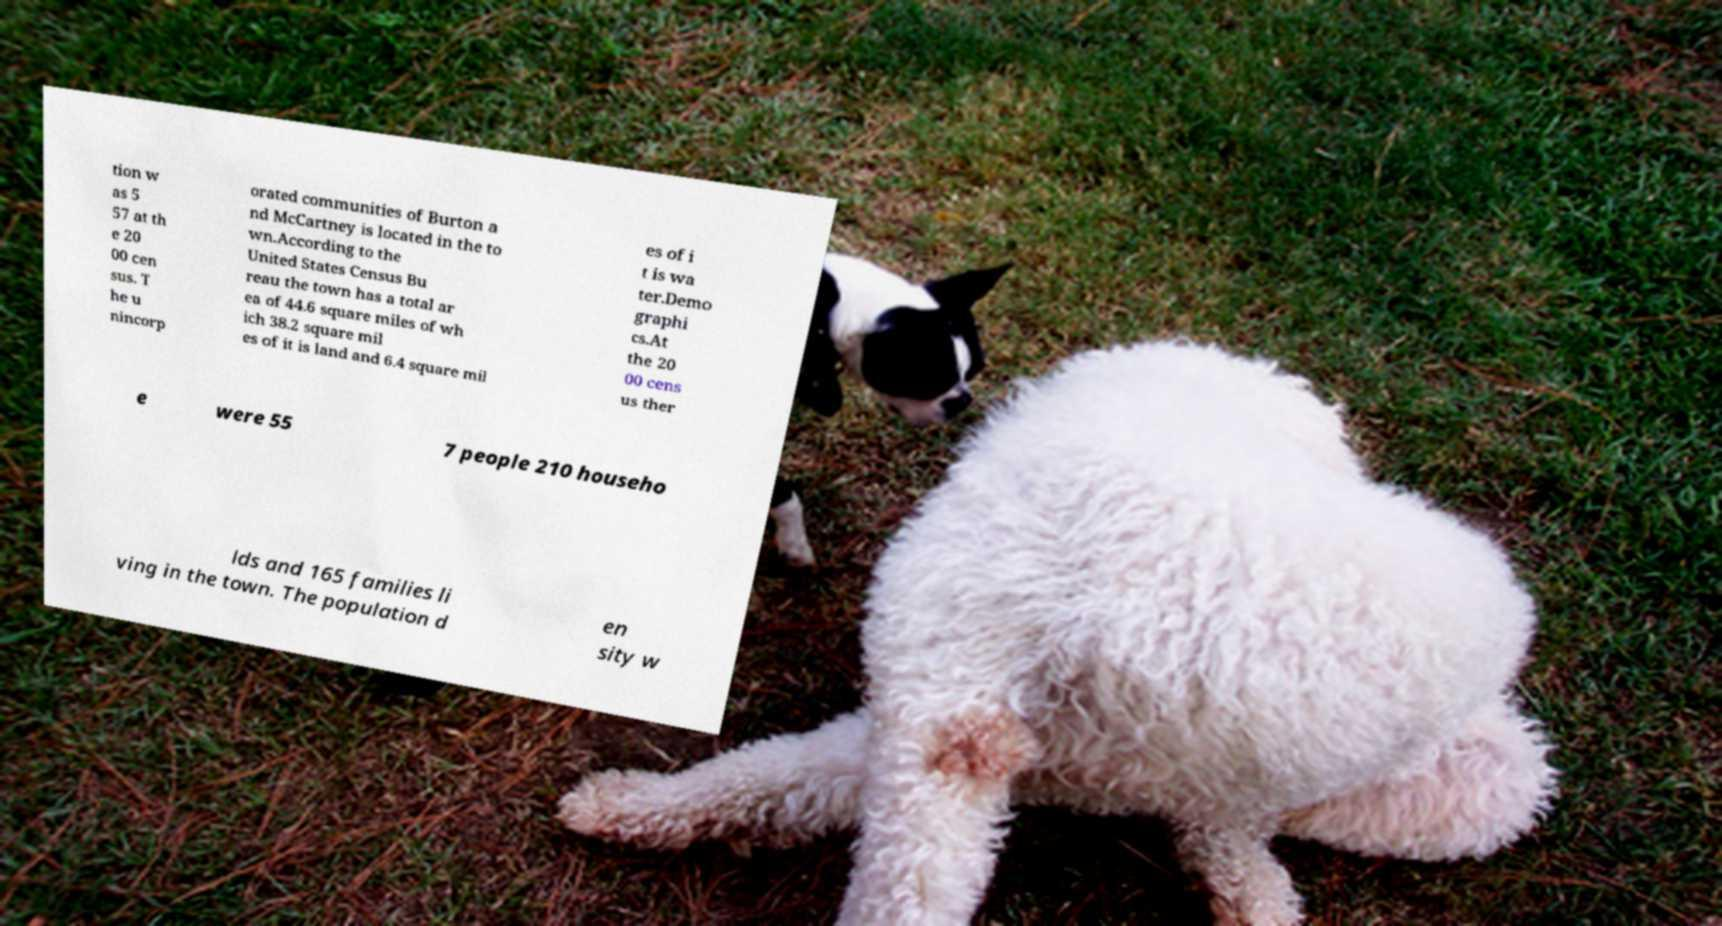Please read and relay the text visible in this image. What does it say? tion w as 5 57 at th e 20 00 cen sus. T he u nincorp orated communities of Burton a nd McCartney is located in the to wn.According to the United States Census Bu reau the town has a total ar ea of 44.6 square miles of wh ich 38.2 square mil es of it is land and 6.4 square mil es of i t is wa ter.Demo graphi cs.At the 20 00 cens us ther e were 55 7 people 210 househo lds and 165 families li ving in the town. The population d en sity w 